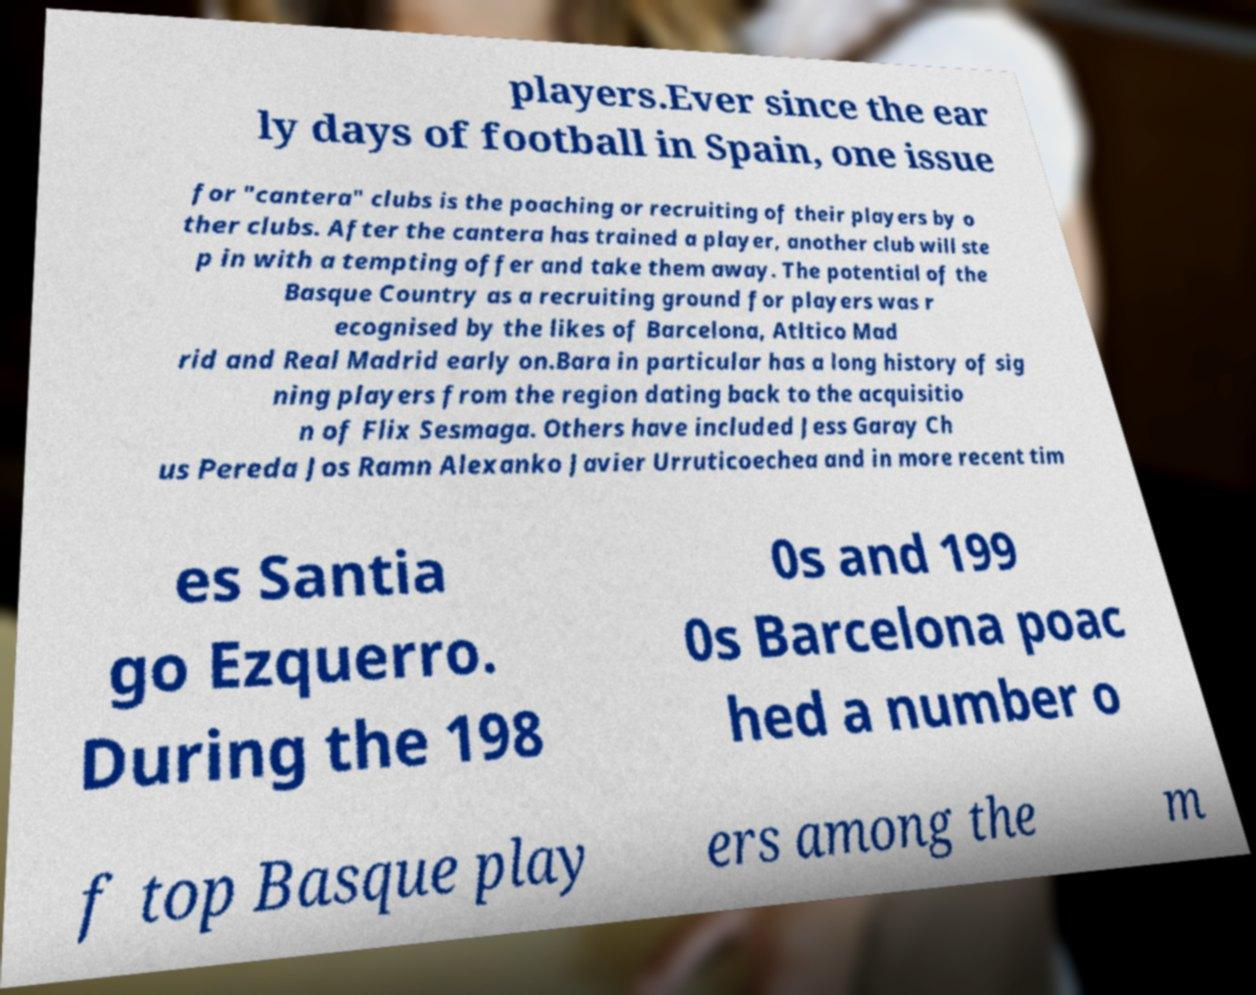For documentation purposes, I need the text within this image transcribed. Could you provide that? players.Ever since the ear ly days of football in Spain, one issue for "cantera" clubs is the poaching or recruiting of their players by o ther clubs. After the cantera has trained a player, another club will ste p in with a tempting offer and take them away. The potential of the Basque Country as a recruiting ground for players was r ecognised by the likes of Barcelona, Atltico Mad rid and Real Madrid early on.Bara in particular has a long history of sig ning players from the region dating back to the acquisitio n of Flix Sesmaga. Others have included Jess Garay Ch us Pereda Jos Ramn Alexanko Javier Urruticoechea and in more recent tim es Santia go Ezquerro. During the 198 0s and 199 0s Barcelona poac hed a number o f top Basque play ers among the m 